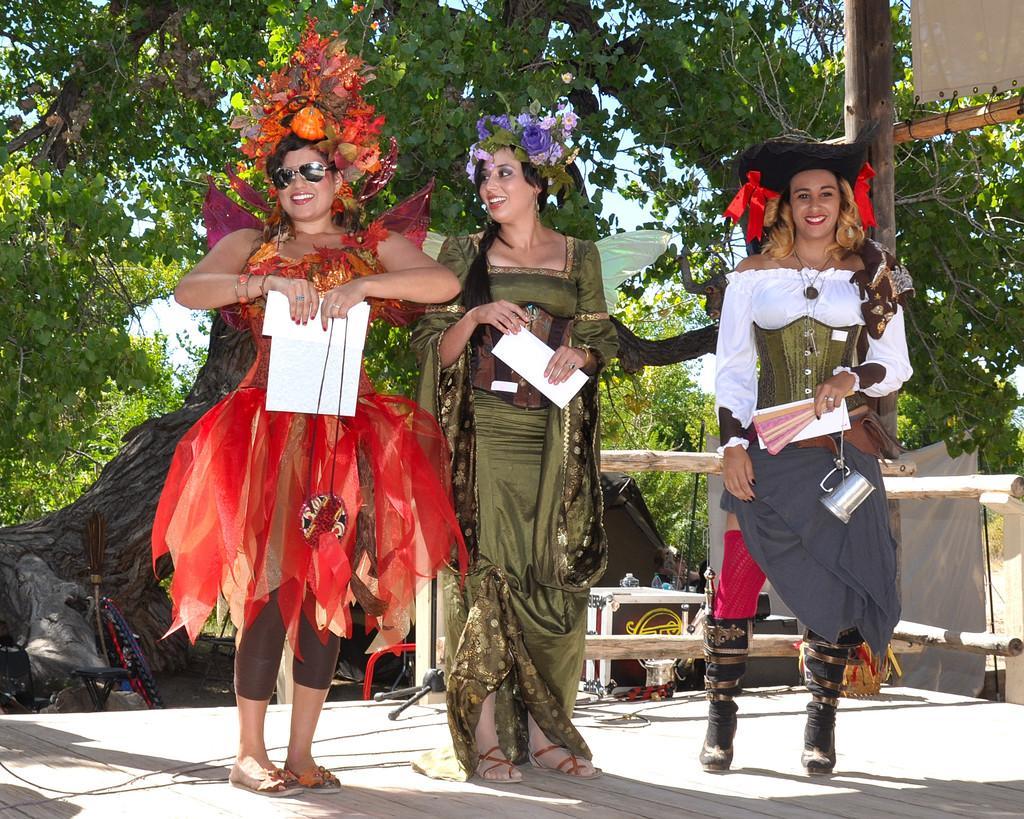Could you give a brief overview of what you see in this image? In this image we can see three women standing on the stage holding some papers. We can also see some wooden poles, trees, a broom, some objects on a table, a cloth and the sky. 